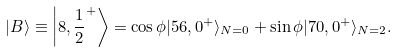<formula> <loc_0><loc_0><loc_500><loc_500>| B \rangle \equiv \left | 8 , { \frac { 1 } { 2 } } ^ { + } \right \rangle = \cos \phi | 5 6 , 0 ^ { + } \rangle _ { N = 0 } + \sin \phi | 7 0 , 0 ^ { + } \rangle _ { N = 2 } .</formula> 